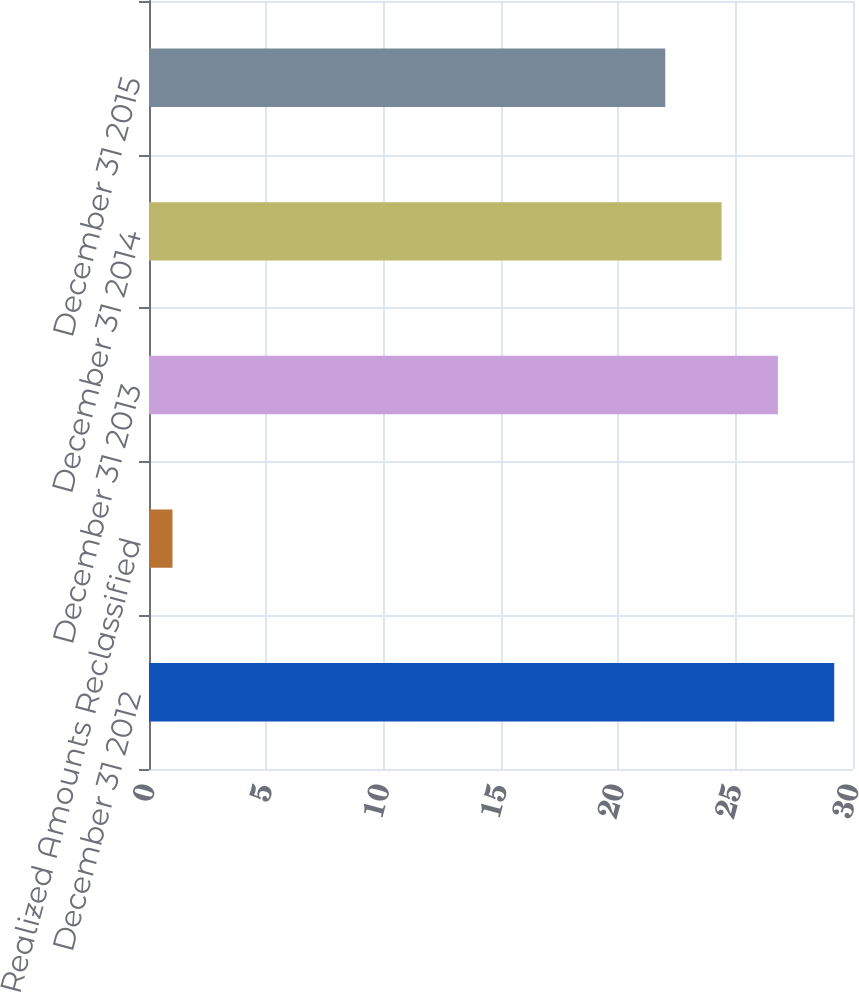Convert chart to OTSL. <chart><loc_0><loc_0><loc_500><loc_500><bar_chart><fcel>December 31 2012<fcel>Realized Amounts Reclassified<fcel>December 31 2013<fcel>December 31 2014<fcel>December 31 2015<nl><fcel>29.2<fcel>1<fcel>26.8<fcel>24.4<fcel>22<nl></chart> 